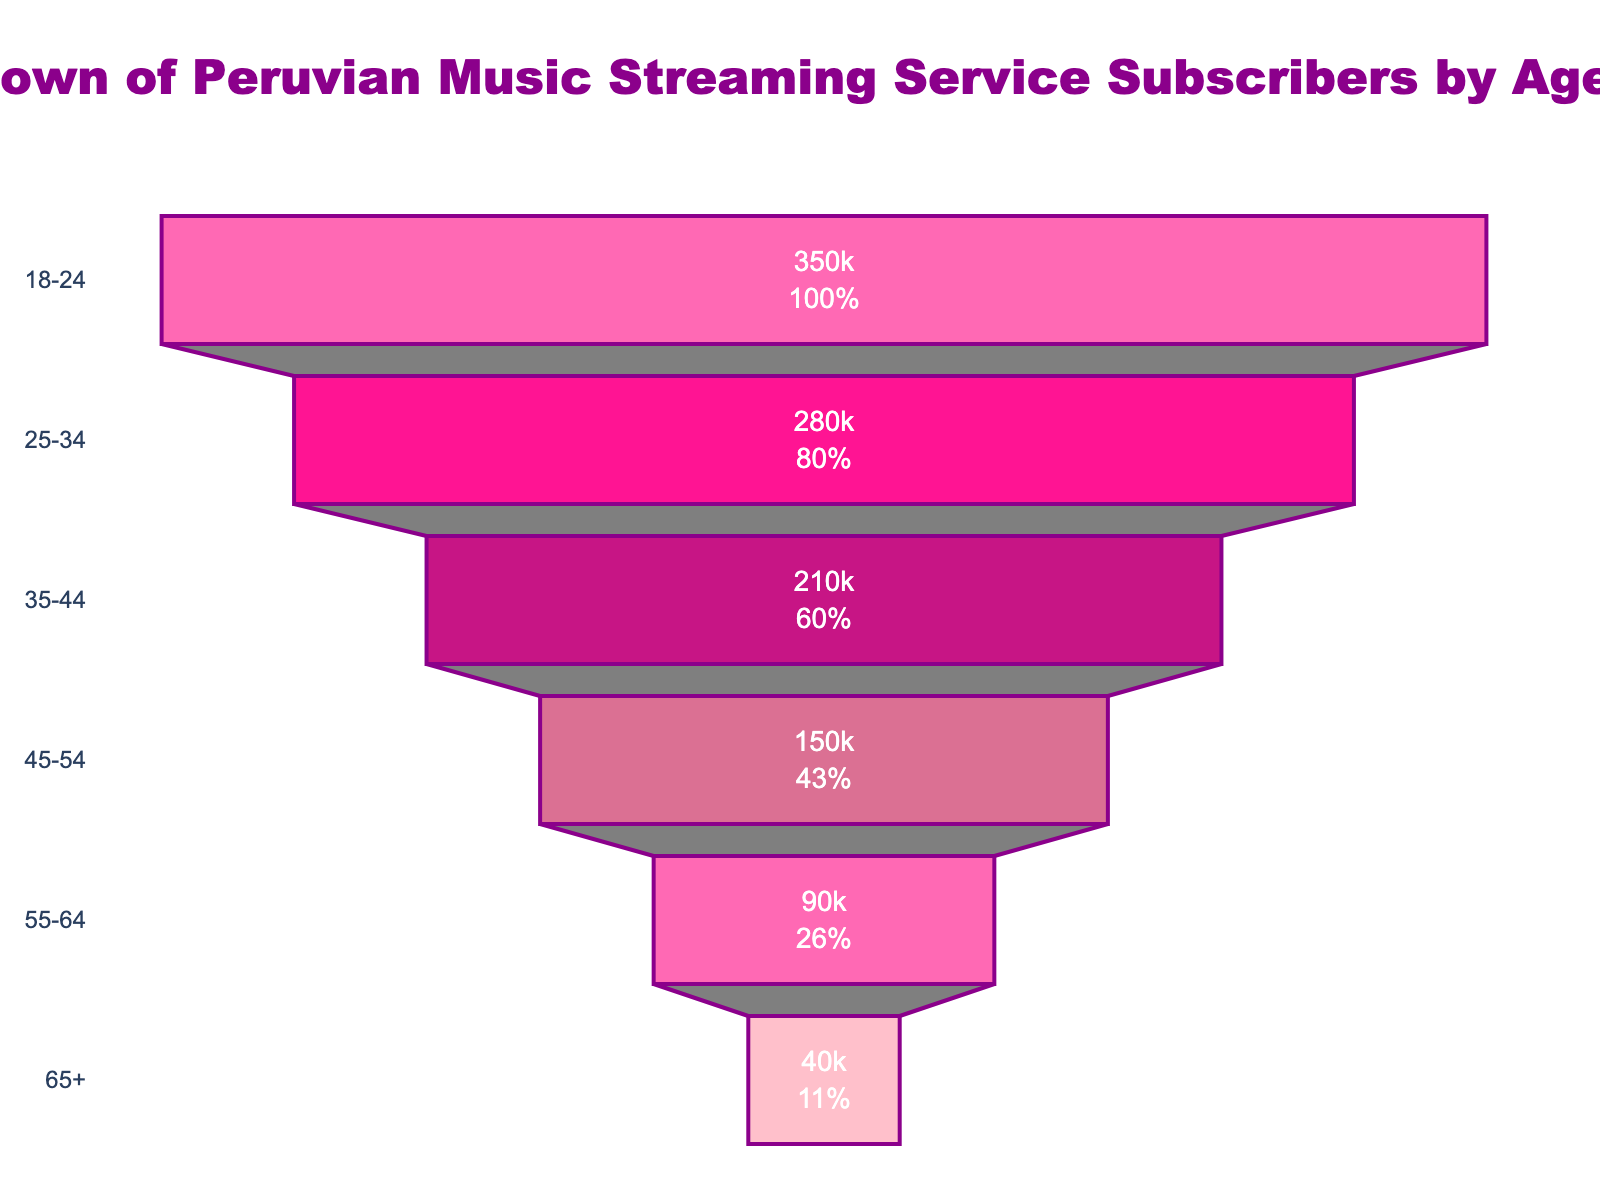How many age groups are represented in the figure? Count the number of age groups listed in the funnel chart.
Answer: 6 Which age group has the highest number of subscribers? Identify the bar with the largest length to find the age group with the highest number of subscribers.
Answer: 18-24 What is the difference in the number of subscribers between the 18-24 and 65+ age groups? Subtract the number of subscribers in the 65+ age group from the number in the 18-24 age group (350000 - 40000).
Answer: 310000 What percentage of the initial population does the 35-44 age group represent? Refer to the figure's text that displays the percentage of the initial value for the 35-44 age group.
Answer: 21% How many subscribers are there in the 45-54 age group? Look at the numerical value displayed inside the funnel for the 45-54 age group.
Answer: 150000 Compare the subscriber numbers of the 25-34 and 55-64 age groups. Which is higher and by how much? Identify the values for both age groups (280000 and 90000 respectively) and subtract the smaller value from the larger one (280000 - 90000).
Answer: 25-34 is higher by 190000 What is the total number of subscribers represented in the figure? Sum the subscribers in all age groups (350000 + 280000 + 210000 + 150000 + 90000 + 40000).
Answer: 1120000 What percentage of the total subscribers belongs to the 55-64 age group? Divide the number of subscribers in the 55-64 age group by the total number of subscribers (90000 / 1120000), and multiply by 100 (approximately 8.04%).
Answer: 8.04% What text information is displayed inside the funnel chart bars? The funnel chart bars show "value+percent initial" information, which includes the subscriber count and the percentage of the initial population.
Answer: Value and percentage What colors are used to represent the bars in the figure? Identify the custom color palette used in the funnel chart: pink-related shades inspired by Tefi Valenzuela's style.
Answer: Pink shades 